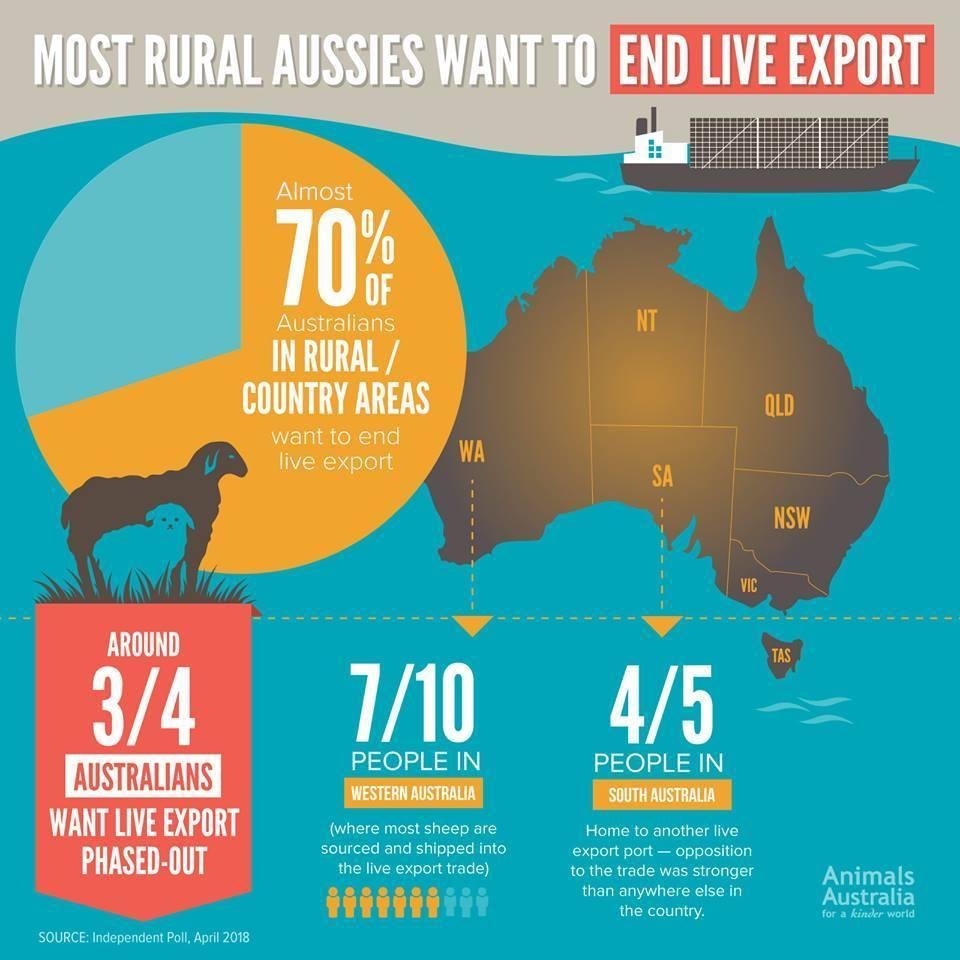how many australians want live export phased-out
Answer the question with a short phrase. 3/4 what percentage of people in south australia want live export phased out? 80 where are most sheep sourced? western australia what percentage of people in western australia want live export phased out? 70 how many sheep are shown in the image 2 what is the percentage of people in rural / country areas that do not want to end live export 30 